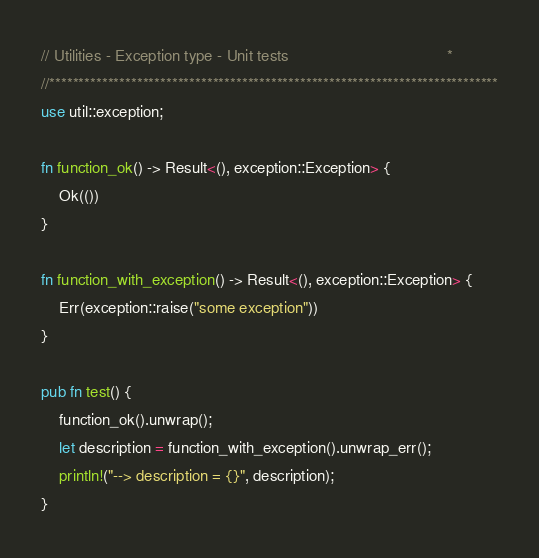Convert code to text. <code><loc_0><loc_0><loc_500><loc_500><_Rust_>// Utilities - Exception type - Unit tests                                    *
//*****************************************************************************
use util::exception;

fn function_ok() -> Result<(), exception::Exception> {
    Ok(())
}

fn function_with_exception() -> Result<(), exception::Exception> {
    Err(exception::raise("some exception"))
}

pub fn test() {
    function_ok().unwrap();
    let description = function_with_exception().unwrap_err();
    println!("--> description = {}", description);
}
</code> 